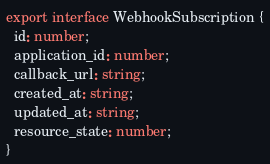Convert code to text. <code><loc_0><loc_0><loc_500><loc_500><_TypeScript_>export interface WebhookSubscription {
  id: number;
  application_id: number;
  callback_url: string;
  created_at: string;
  updated_at: string;
  resource_state: number;
}
</code> 